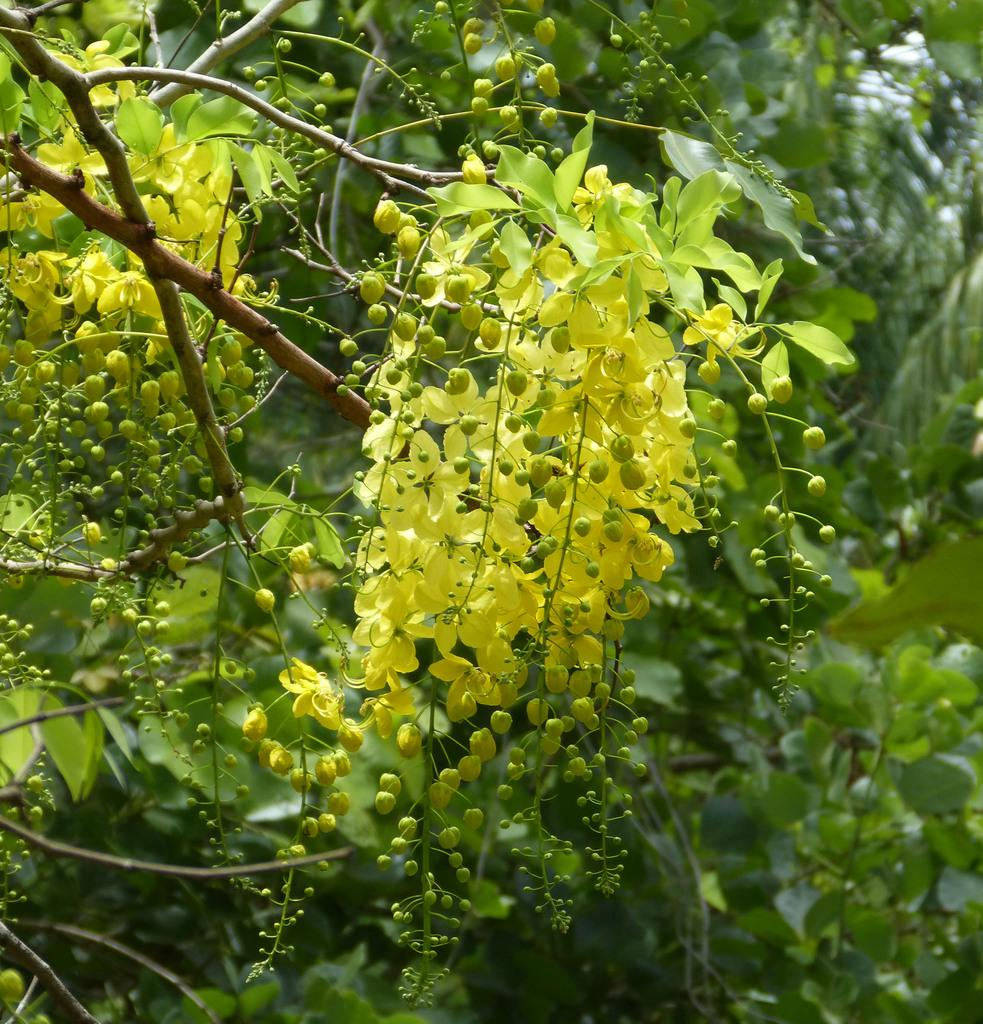What type of plant material can be seen in the image? There are green leaves, stems, and buds in the image. Can you describe the growth stage of the plants in the image? The presence of buds suggests that the plants are in the early stages of growth. What color are the leaves in the image? The leaves in the image are green. What type of force is being applied to the leaves in the image? There is no force being applied to the leaves in the image; they are stationary and not interacting with any external forces. 